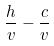Convert formula to latex. <formula><loc_0><loc_0><loc_500><loc_500>\frac { h } { v } - \frac { c } { v }</formula> 